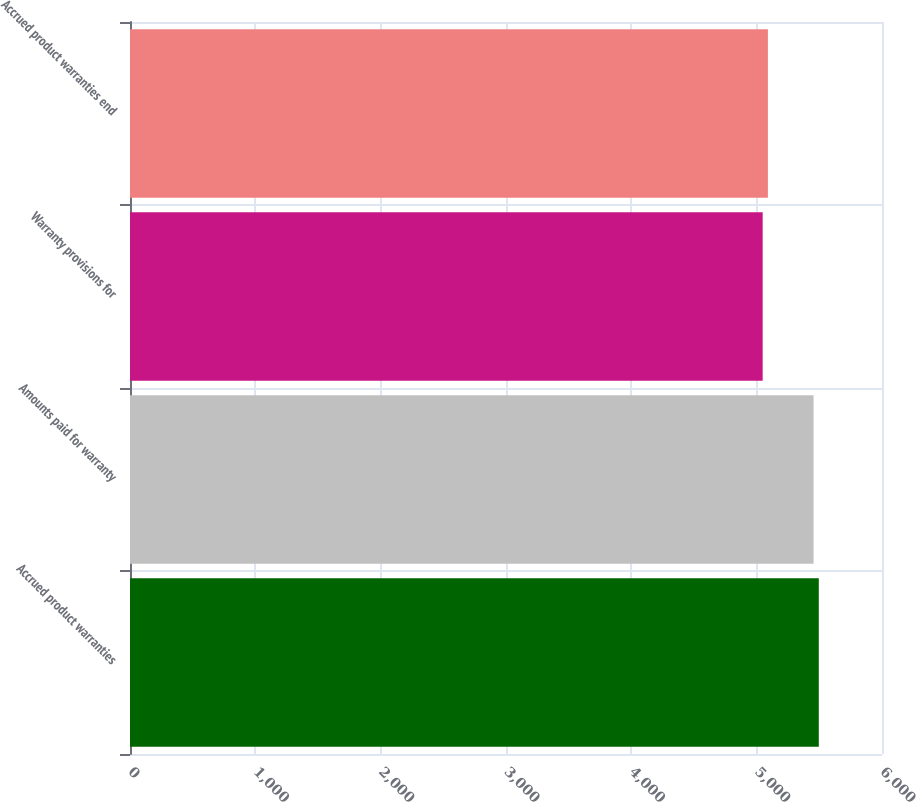<chart> <loc_0><loc_0><loc_500><loc_500><bar_chart><fcel>Accrued product warranties<fcel>Amounts paid for warranty<fcel>Warranty provisions for<fcel>Accrued product warranties end<nl><fcel>5495.7<fcel>5454<fcel>5048<fcel>5089.7<nl></chart> 